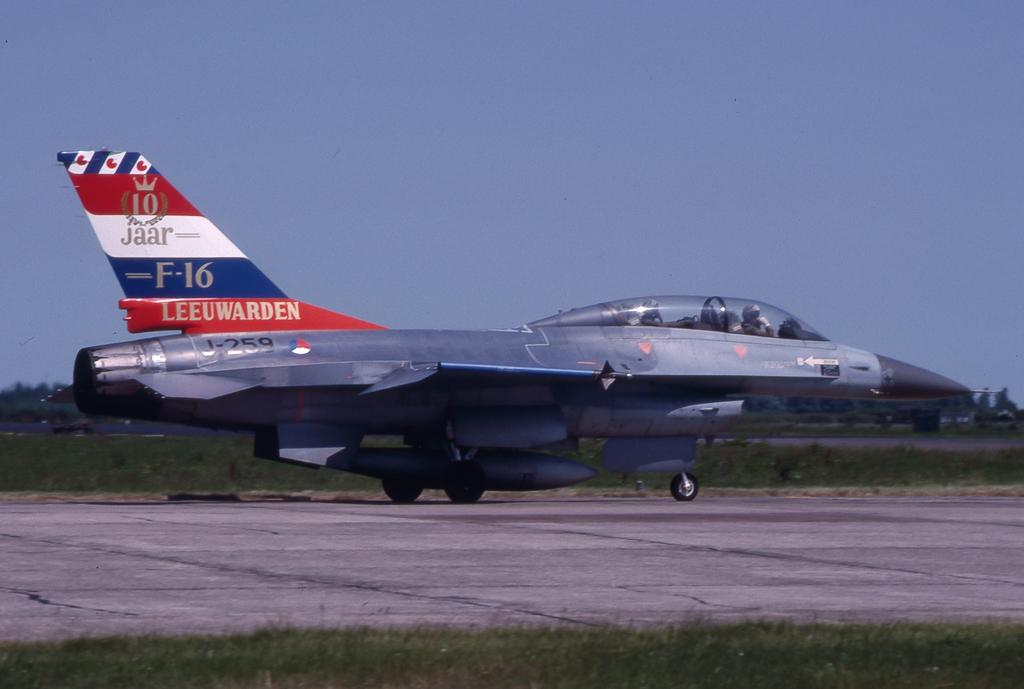<image>
Share a concise interpretation of the image provided. The tail of a military plain on the tarmac is red, white and blue and has the name Leeuwarden at the bottom of it. 